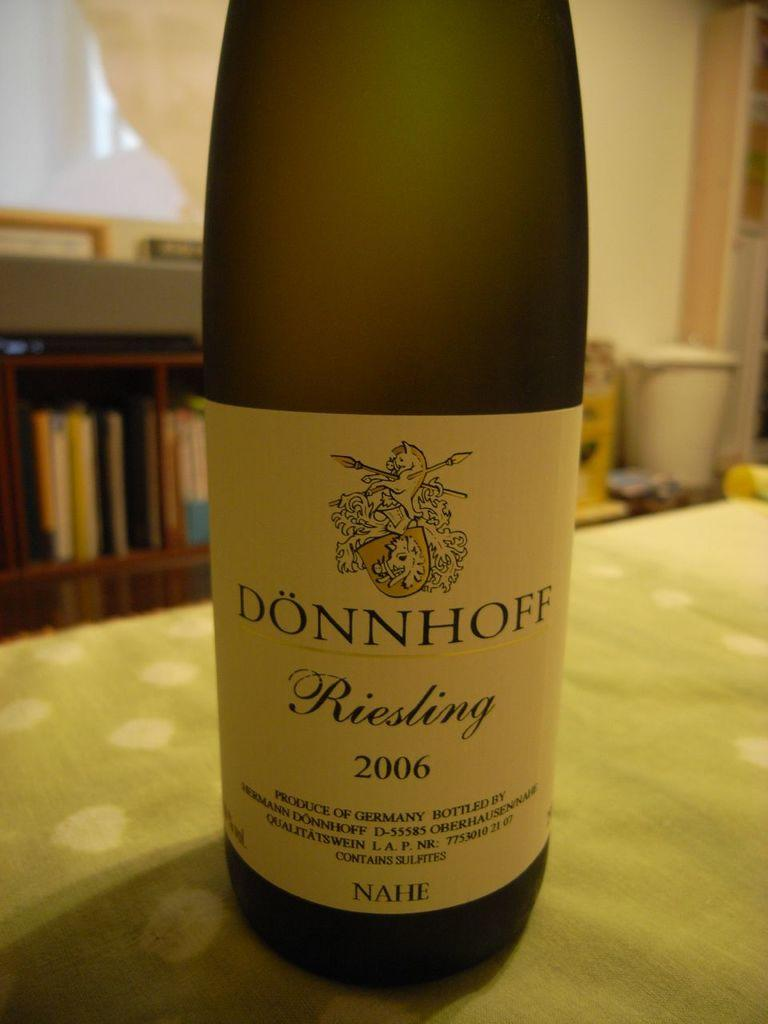<image>
Give a short and clear explanation of the subsequent image. A bottle of Donnhoff Riesling from 2006 sitting on a table. 